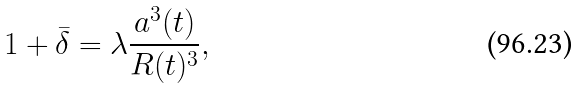<formula> <loc_0><loc_0><loc_500><loc_500>1 + \bar { \delta } = \lambda \frac { a ^ { 3 } ( t ) } { R ( t ) ^ { 3 } } ,</formula> 